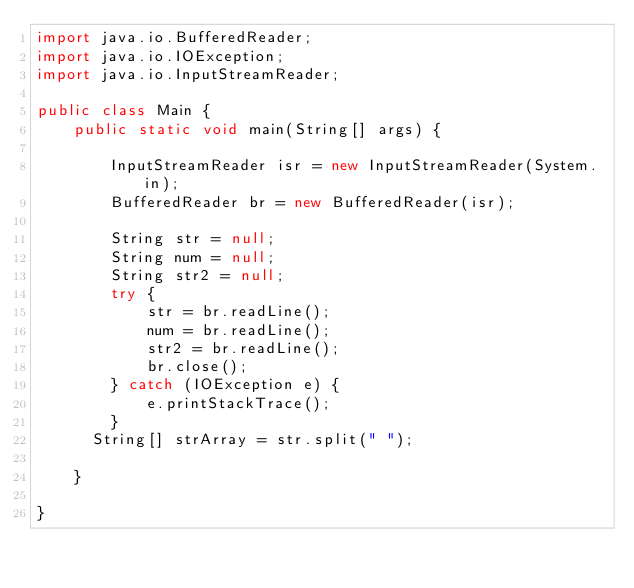Convert code to text. <code><loc_0><loc_0><loc_500><loc_500><_Java_>import java.io.BufferedReader;
import java.io.IOException;
import java.io.InputStreamReader;
 
public class Main {
    public static void main(String[] args) {
 
        InputStreamReader isr = new InputStreamReader(System.in);
        BufferedReader br = new BufferedReader(isr);
 
        String str = null;
        String num = null;
        String str2 = null;
        try {
            str = br.readLine();
            num = br.readLine();
            str2 = br.readLine();
            br.close();
        } catch (IOException e) {
            e.printStackTrace();
        }
      String[] strArray = str.split(" "); 
 
    }
 
}</code> 